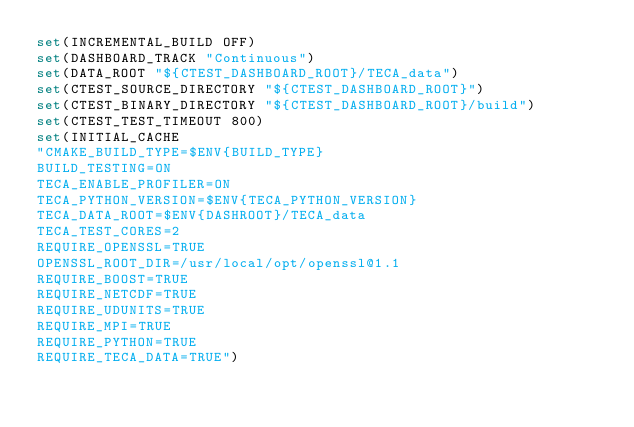<code> <loc_0><loc_0><loc_500><loc_500><_CMake_>set(INCREMENTAL_BUILD OFF)
set(DASHBOARD_TRACK "Continuous")
set(DATA_ROOT "${CTEST_DASHBOARD_ROOT}/TECA_data")
set(CTEST_SOURCE_DIRECTORY "${CTEST_DASHBOARD_ROOT}")
set(CTEST_BINARY_DIRECTORY "${CTEST_DASHBOARD_ROOT}/build")
set(CTEST_TEST_TIMEOUT 800)
set(INITIAL_CACHE
"CMAKE_BUILD_TYPE=$ENV{BUILD_TYPE}
BUILD_TESTING=ON
TECA_ENABLE_PROFILER=ON
TECA_PYTHON_VERSION=$ENV{TECA_PYTHON_VERSION}
TECA_DATA_ROOT=$ENV{DASHROOT}/TECA_data
TECA_TEST_CORES=2
REQUIRE_OPENSSL=TRUE
OPENSSL_ROOT_DIR=/usr/local/opt/openssl@1.1
REQUIRE_BOOST=TRUE
REQUIRE_NETCDF=TRUE
REQUIRE_UDUNITS=TRUE
REQUIRE_MPI=TRUE
REQUIRE_PYTHON=TRUE
REQUIRE_TECA_DATA=TRUE")</code> 